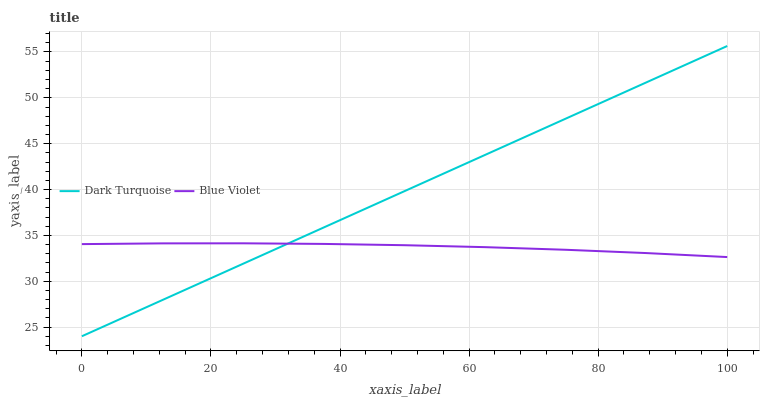Does Blue Violet have the minimum area under the curve?
Answer yes or no. Yes. Does Dark Turquoise have the maximum area under the curve?
Answer yes or no. Yes. Does Blue Violet have the maximum area under the curve?
Answer yes or no. No. Is Dark Turquoise the smoothest?
Answer yes or no. Yes. Is Blue Violet the roughest?
Answer yes or no. Yes. Is Blue Violet the smoothest?
Answer yes or no. No. Does Dark Turquoise have the lowest value?
Answer yes or no. Yes. Does Blue Violet have the lowest value?
Answer yes or no. No. Does Dark Turquoise have the highest value?
Answer yes or no. Yes. Does Blue Violet have the highest value?
Answer yes or no. No. Does Dark Turquoise intersect Blue Violet?
Answer yes or no. Yes. Is Dark Turquoise less than Blue Violet?
Answer yes or no. No. Is Dark Turquoise greater than Blue Violet?
Answer yes or no. No. 